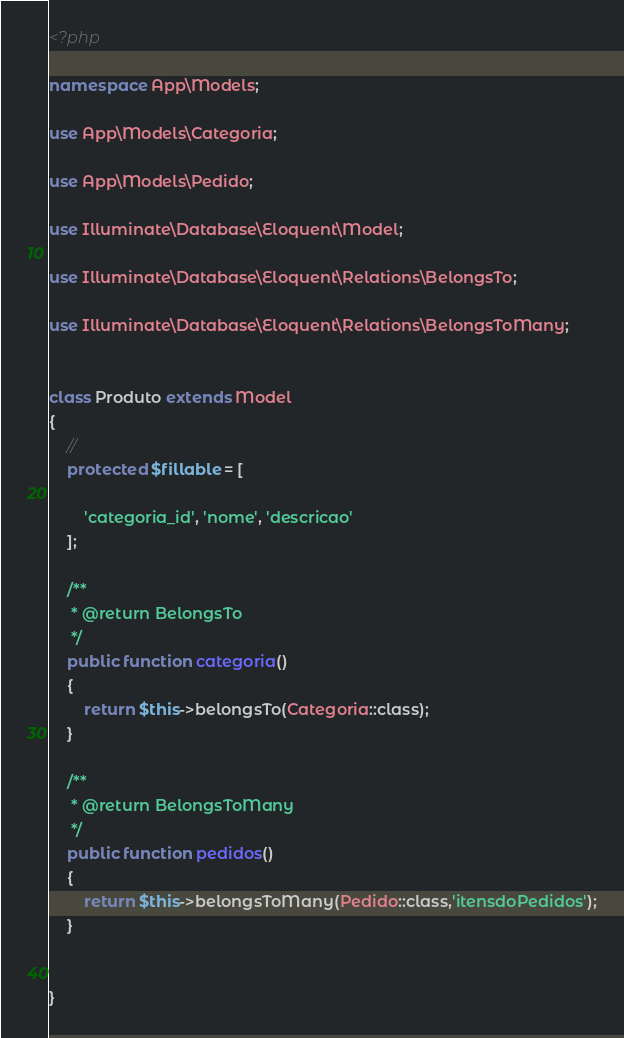<code> <loc_0><loc_0><loc_500><loc_500><_PHP_><?php

namespace App\Models;

use App\Models\Categoria;

use App\Models\Pedido;

use Illuminate\Database\Eloquent\Model;

use Illuminate\Database\Eloquent\Relations\BelongsTo;

use Illuminate\Database\Eloquent\Relations\BelongsToMany;


class Produto extends Model
{
    //
    protected $fillable = [

        'categoria_id', 'nome', 'descricao'
    ];

    /**
     * @return BelongsTo
     */
    public function categoria()
    {
        return $this->belongsTo(Categoria::class);
    }

    /**
     * @return BelongsToMany
     */
    public function pedidos()
    {
        return $this->belongsToMany(Pedido::class,'itensdoPedidos');
    }


}
</code> 